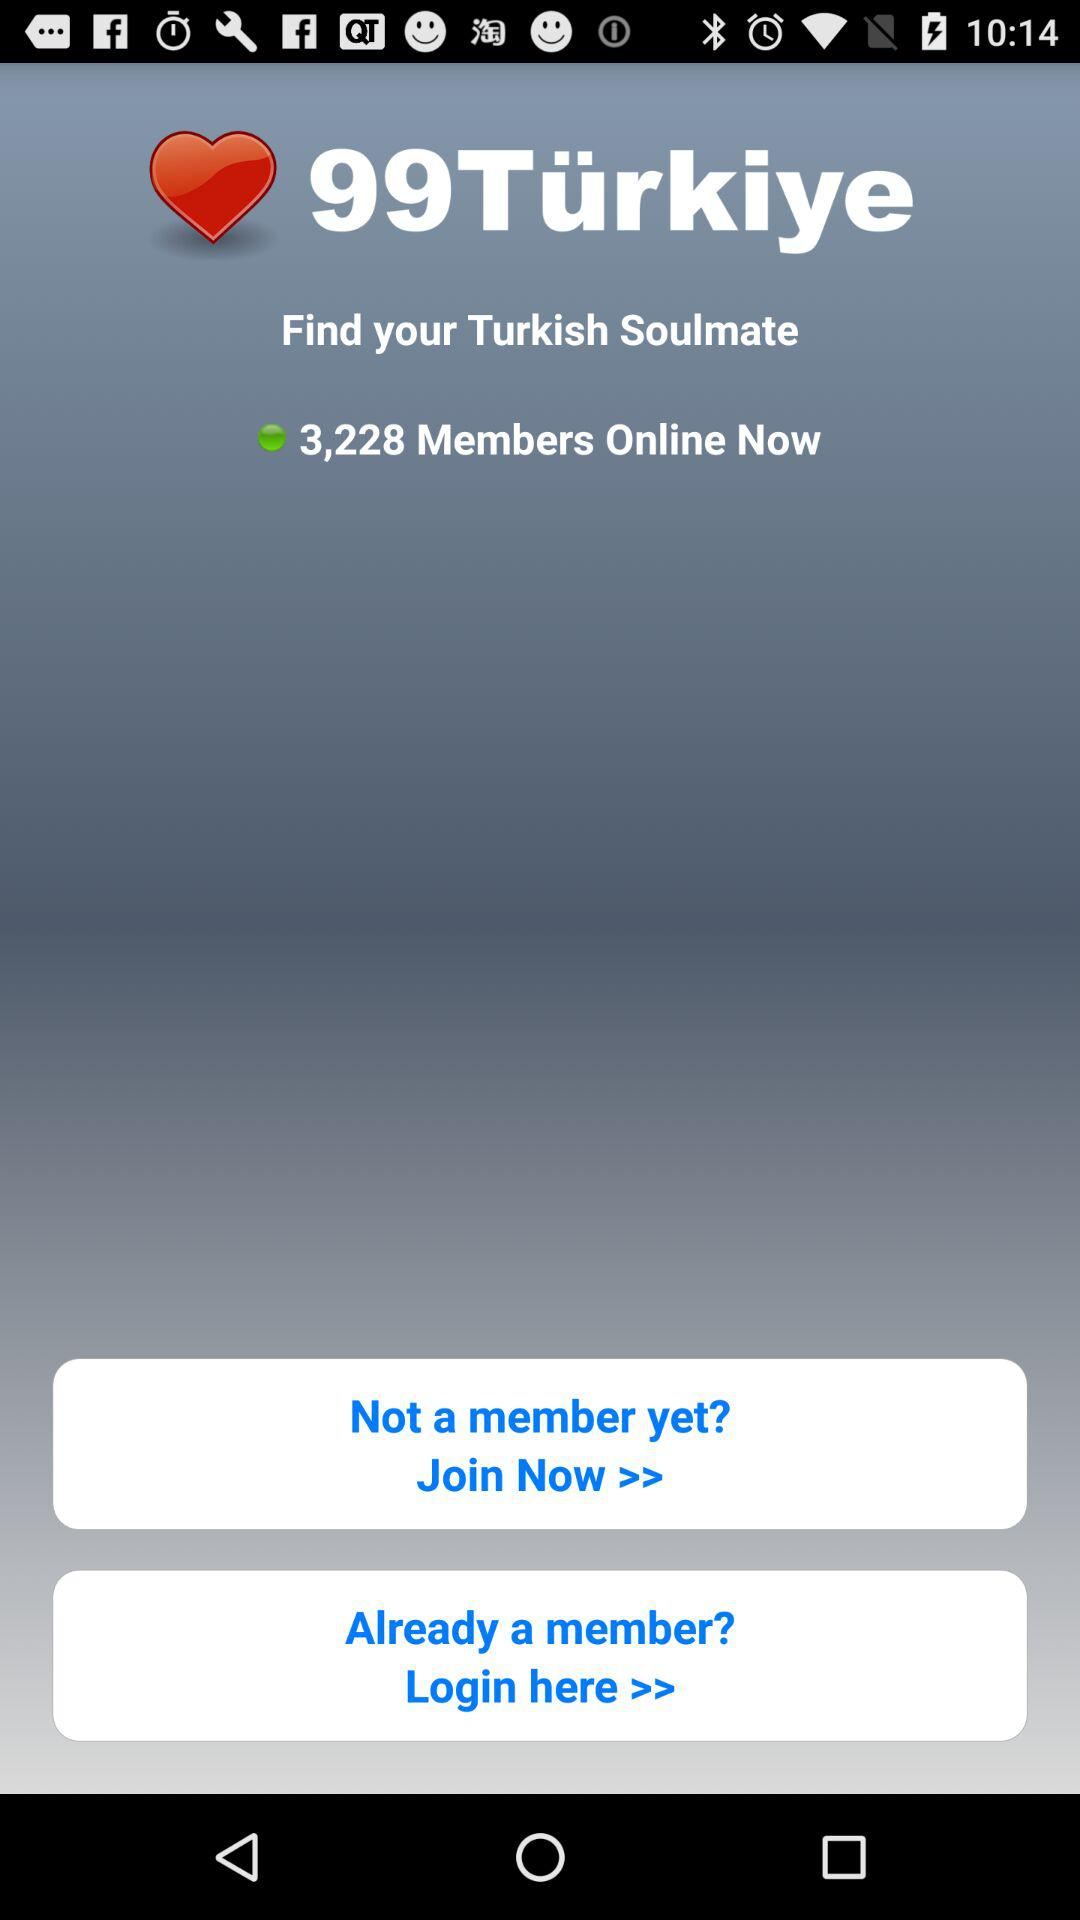How many members are online now? There are 3,228 members online now. 